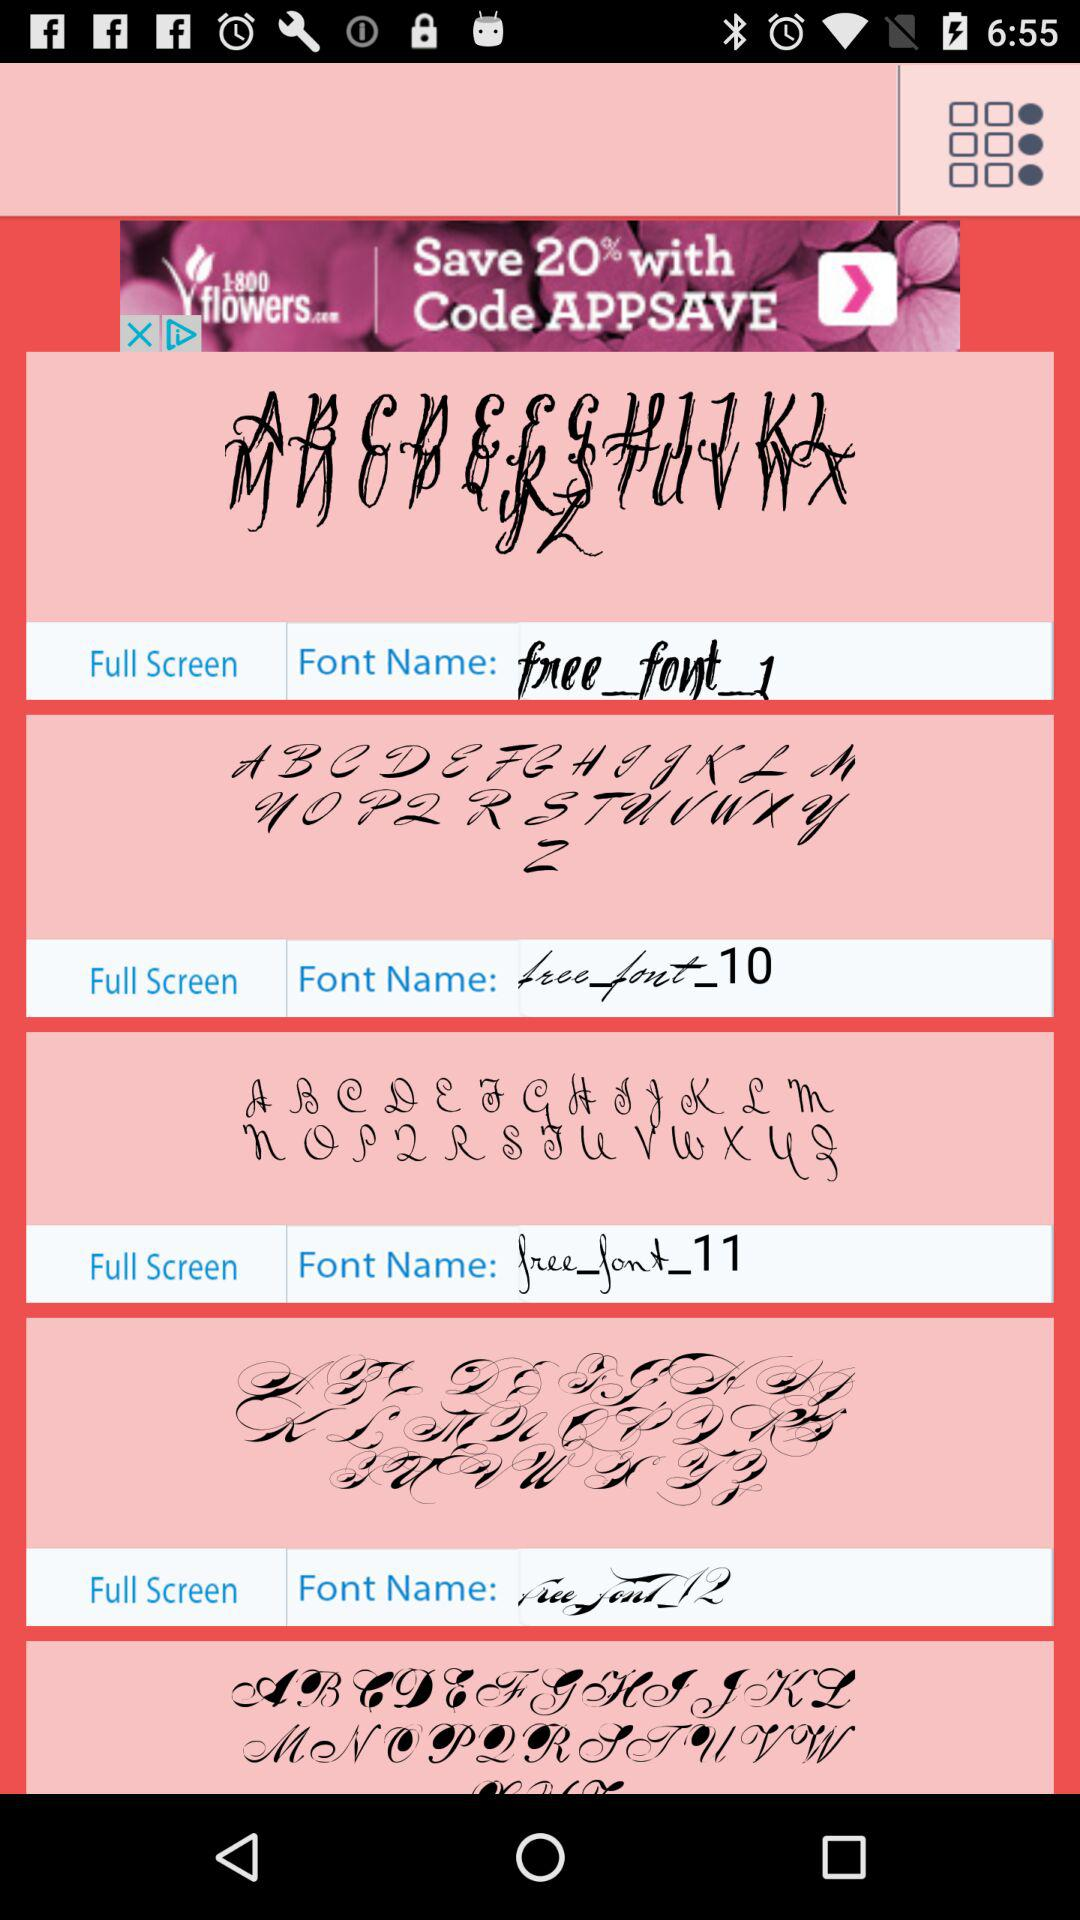What are the names of the fonts? The names of the fonts are: "free_font_1", "free font_10", "free_font_11", and "free_font_12". 